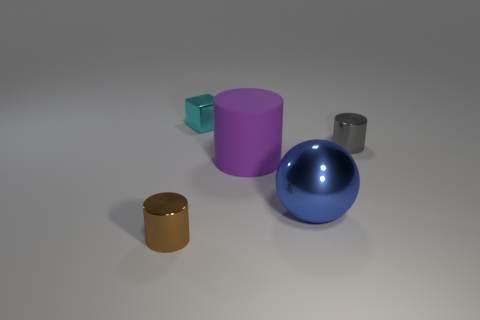Is there any other thing that has the same material as the purple object?
Provide a short and direct response. No. Is the number of blue cylinders greater than the number of brown cylinders?
Give a very brief answer. No. How many other things are the same shape as the tiny cyan shiny object?
Your answer should be very brief. 0. Is the large matte cylinder the same color as the big metallic object?
Offer a very short reply. No. There is a object that is both behind the purple object and right of the big cylinder; what is its material?
Your answer should be compact. Metal. What size is the brown metal object?
Offer a terse response. Small. There is a tiny metal cylinder on the right side of the metallic cylinder that is in front of the big blue metallic object; what number of small gray metallic objects are on the left side of it?
Your answer should be compact. 0. There is a object behind the cylinder on the right side of the large purple cylinder; what is its shape?
Your answer should be compact. Cube. There is a brown object that is the same shape as the purple thing; what is its size?
Give a very brief answer. Small. Is there anything else that is the same size as the blue shiny object?
Provide a short and direct response. Yes. 